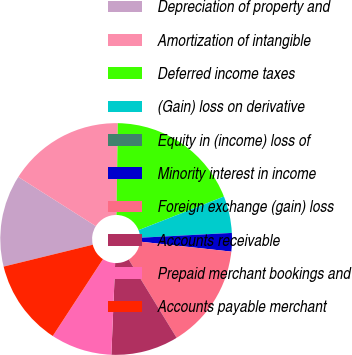Convert chart to OTSL. <chart><loc_0><loc_0><loc_500><loc_500><pie_chart><fcel>Depreciation of property and<fcel>Amortization of intangible<fcel>Deferred income taxes<fcel>(Gain) loss on derivative<fcel>Equity in (income) loss of<fcel>Minority interest in income<fcel>Foreign exchange (gain) loss<fcel>Accounts receivable<fcel>Prepaid merchant bookings and<fcel>Accounts payable merchant<nl><fcel>12.82%<fcel>16.23%<fcel>18.79%<fcel>5.13%<fcel>0.01%<fcel>2.57%<fcel>14.52%<fcel>9.4%<fcel>8.55%<fcel>11.96%<nl></chart> 